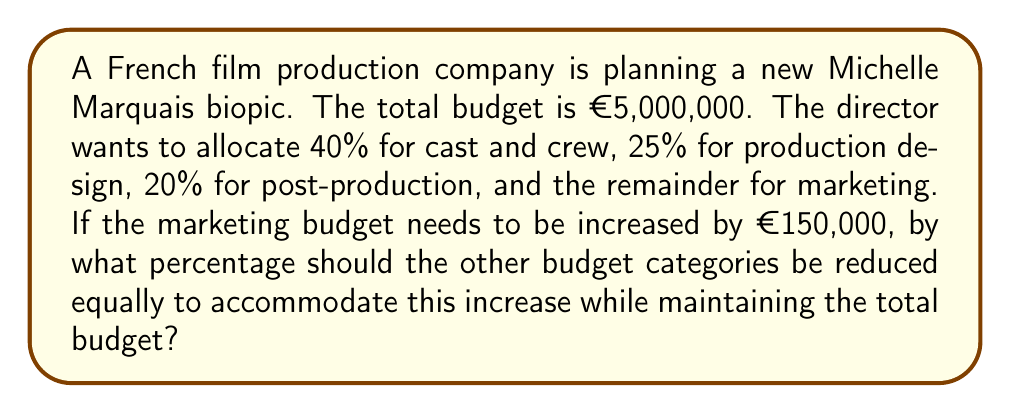Teach me how to tackle this problem. Let's approach this step-by-step:

1) First, calculate the initial allocations:
   Cast and crew: $0.40 \times €5,000,000 = €2,000,000$
   Production design: $0.25 \times €5,000,000 = €1,250,000$
   Post-production: $0.20 \times €5,000,000 = €1,000,000$
   Marketing: $0.15 \times €5,000,000 = €750,000$

2) The new marketing budget:
   $€750,000 + €150,000 = €900,000$

3) The amount that needs to be reduced from other categories:
   $€900,000 - €750,000 = €150,000$

4) The total of the other categories:
   $€2,000,000 + €1,250,000 + €1,000,000 = €4,250,000$

5) To find the percentage reduction, we divide the amount to be reduced by the total of the other categories:
   $\frac{€150,000}{€4,250,000} = 0.0352941176$

6) Convert to percentage:
   $0.0352941176 \times 100\% = 3.52941176\%$

Therefore, each of the other budget categories needs to be reduced by approximately 3.53% to accommodate the increase in the marketing budget while maintaining the total budget.
Answer: 3.53% 